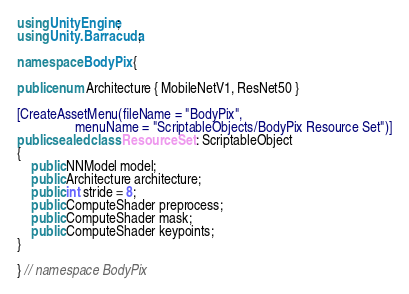Convert code to text. <code><loc_0><loc_0><loc_500><loc_500><_C#_>using UnityEngine;
using Unity.Barracuda;

namespace BodyPix {

public enum Architecture { MobileNetV1, ResNet50 }

[CreateAssetMenu(fileName = "BodyPix",
                 menuName = "ScriptableObjects/BodyPix Resource Set")]
public sealed class ResourceSet : ScriptableObject
{
    public NNModel model;
    public Architecture architecture;
    public int stride = 8;
    public ComputeShader preprocess;
    public ComputeShader mask;
    public ComputeShader keypoints;
}

} // namespace BodyPix
</code> 